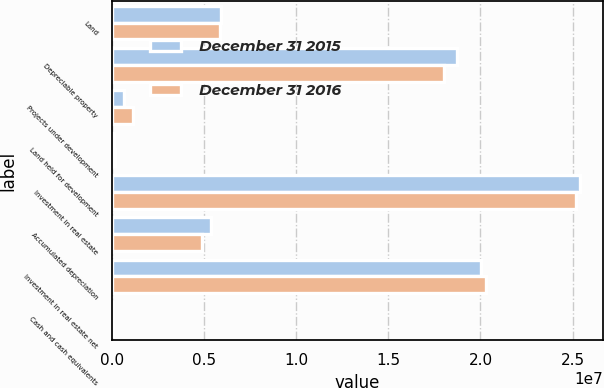Convert chart to OTSL. <chart><loc_0><loc_0><loc_500><loc_500><stacked_bar_chart><ecel><fcel>Land<fcel>Depreciable property<fcel>Projects under development<fcel>Land held for development<fcel>Investment in real estate<fcel>Accumulated depreciation<fcel>Investment in real estate net<fcel>Cash and cash equivalents<nl><fcel>December 31 2015<fcel>5.89986e+06<fcel>1.87306e+07<fcel>637168<fcel>118816<fcel>2.53864e+07<fcel>5.36039e+06<fcel>2.0026e+07<fcel>77207<nl><fcel>December 31 2016<fcel>5.86405e+06<fcel>1.80371e+07<fcel>1.12238e+06<fcel>158843<fcel>2.51824e+07<fcel>4.90541e+06<fcel>2.02769e+07<fcel>42276<nl></chart> 